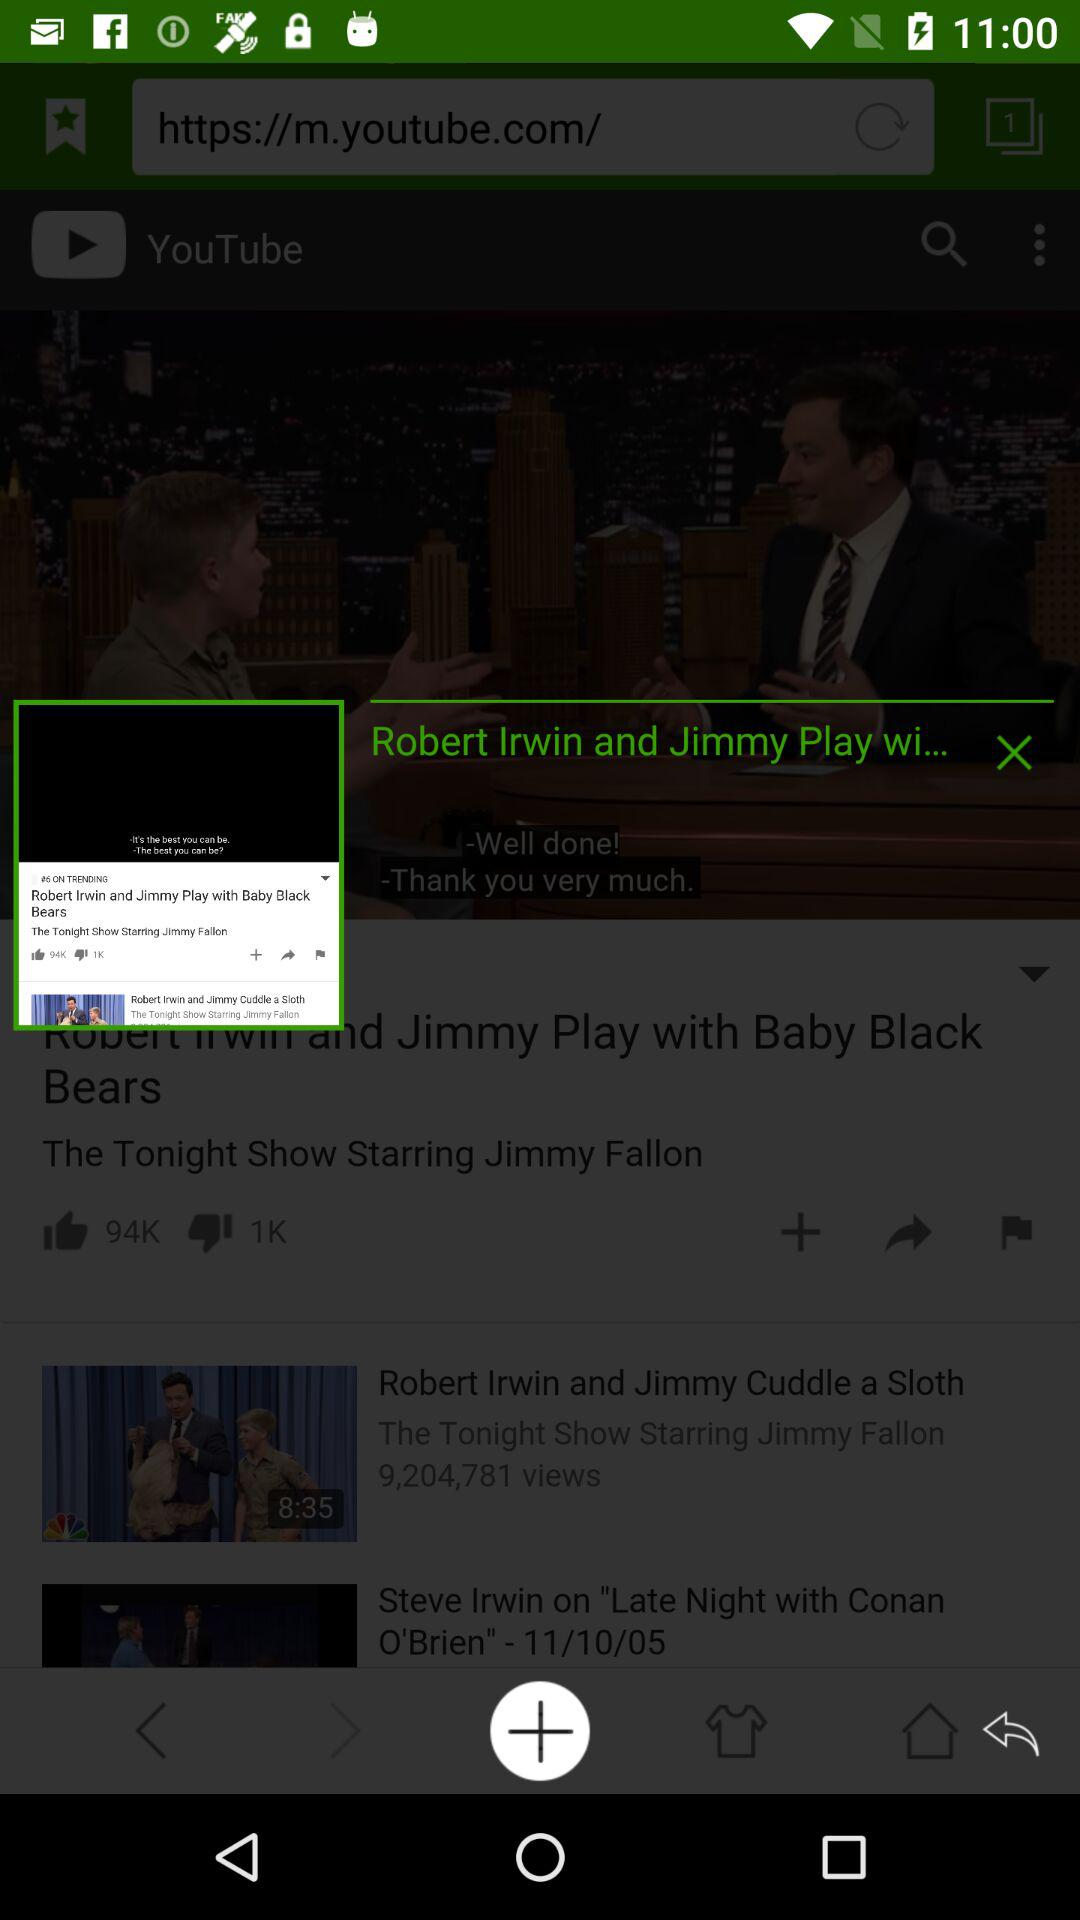How many dislikes did the video get? The video got 1K dislikes. 